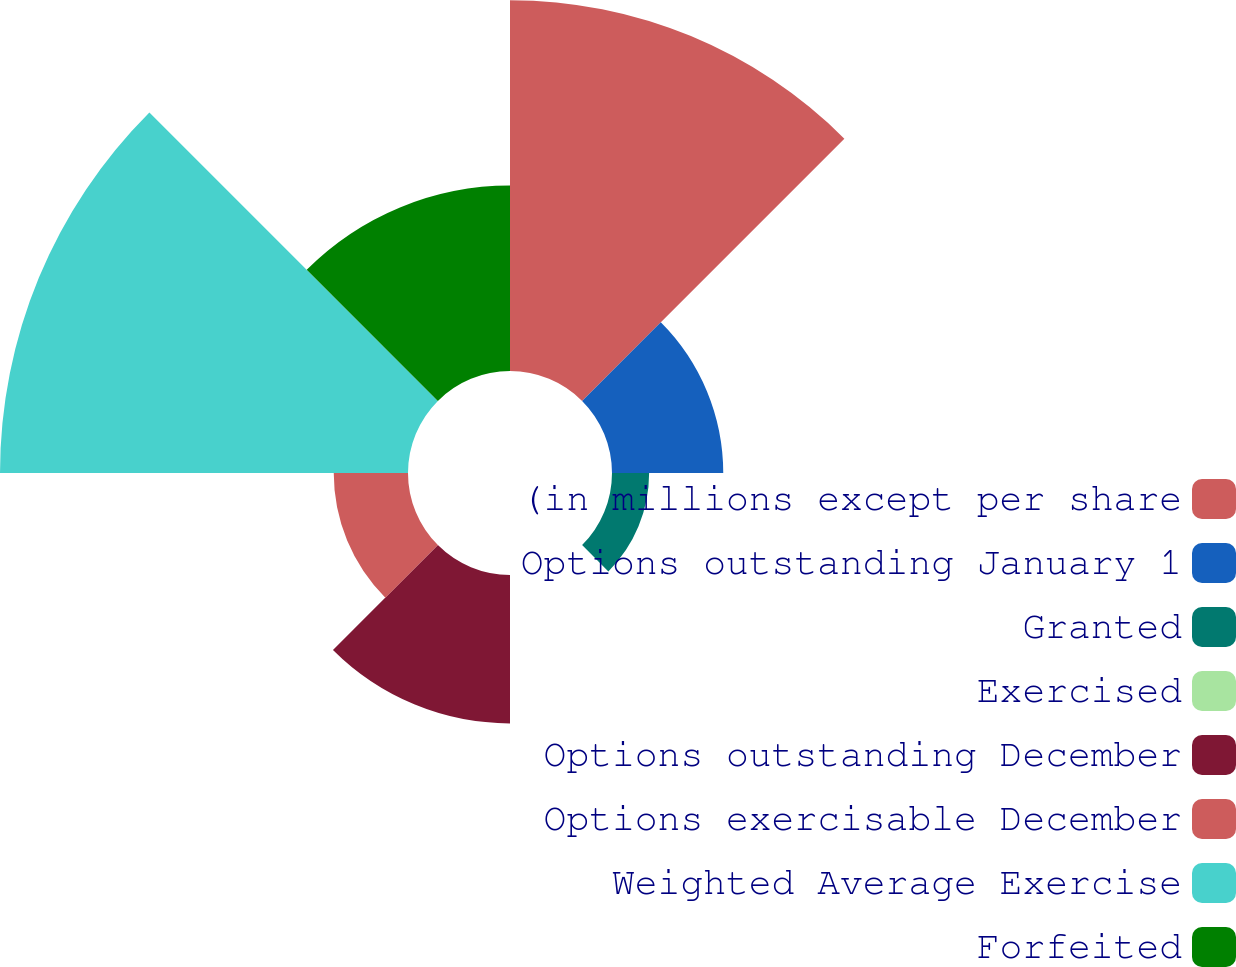Convert chart. <chart><loc_0><loc_0><loc_500><loc_500><pie_chart><fcel>(in millions except per share<fcel>Options outstanding January 1<fcel>Granted<fcel>Exercised<fcel>Options outstanding December<fcel>Options exercisable December<fcel>Weighted Average Exercise<fcel>Forfeited<nl><fcel>27.77%<fcel>8.33%<fcel>2.78%<fcel>0.0%<fcel>11.11%<fcel>5.56%<fcel>30.55%<fcel>13.89%<nl></chart> 